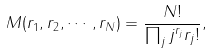Convert formula to latex. <formula><loc_0><loc_0><loc_500><loc_500>M ( r _ { 1 } , r _ { 2 } , \cdots , r _ { N } ) = \frac { N ! } { \prod _ { j } j ^ { r _ { j } } r _ { j } ! } ,</formula> 